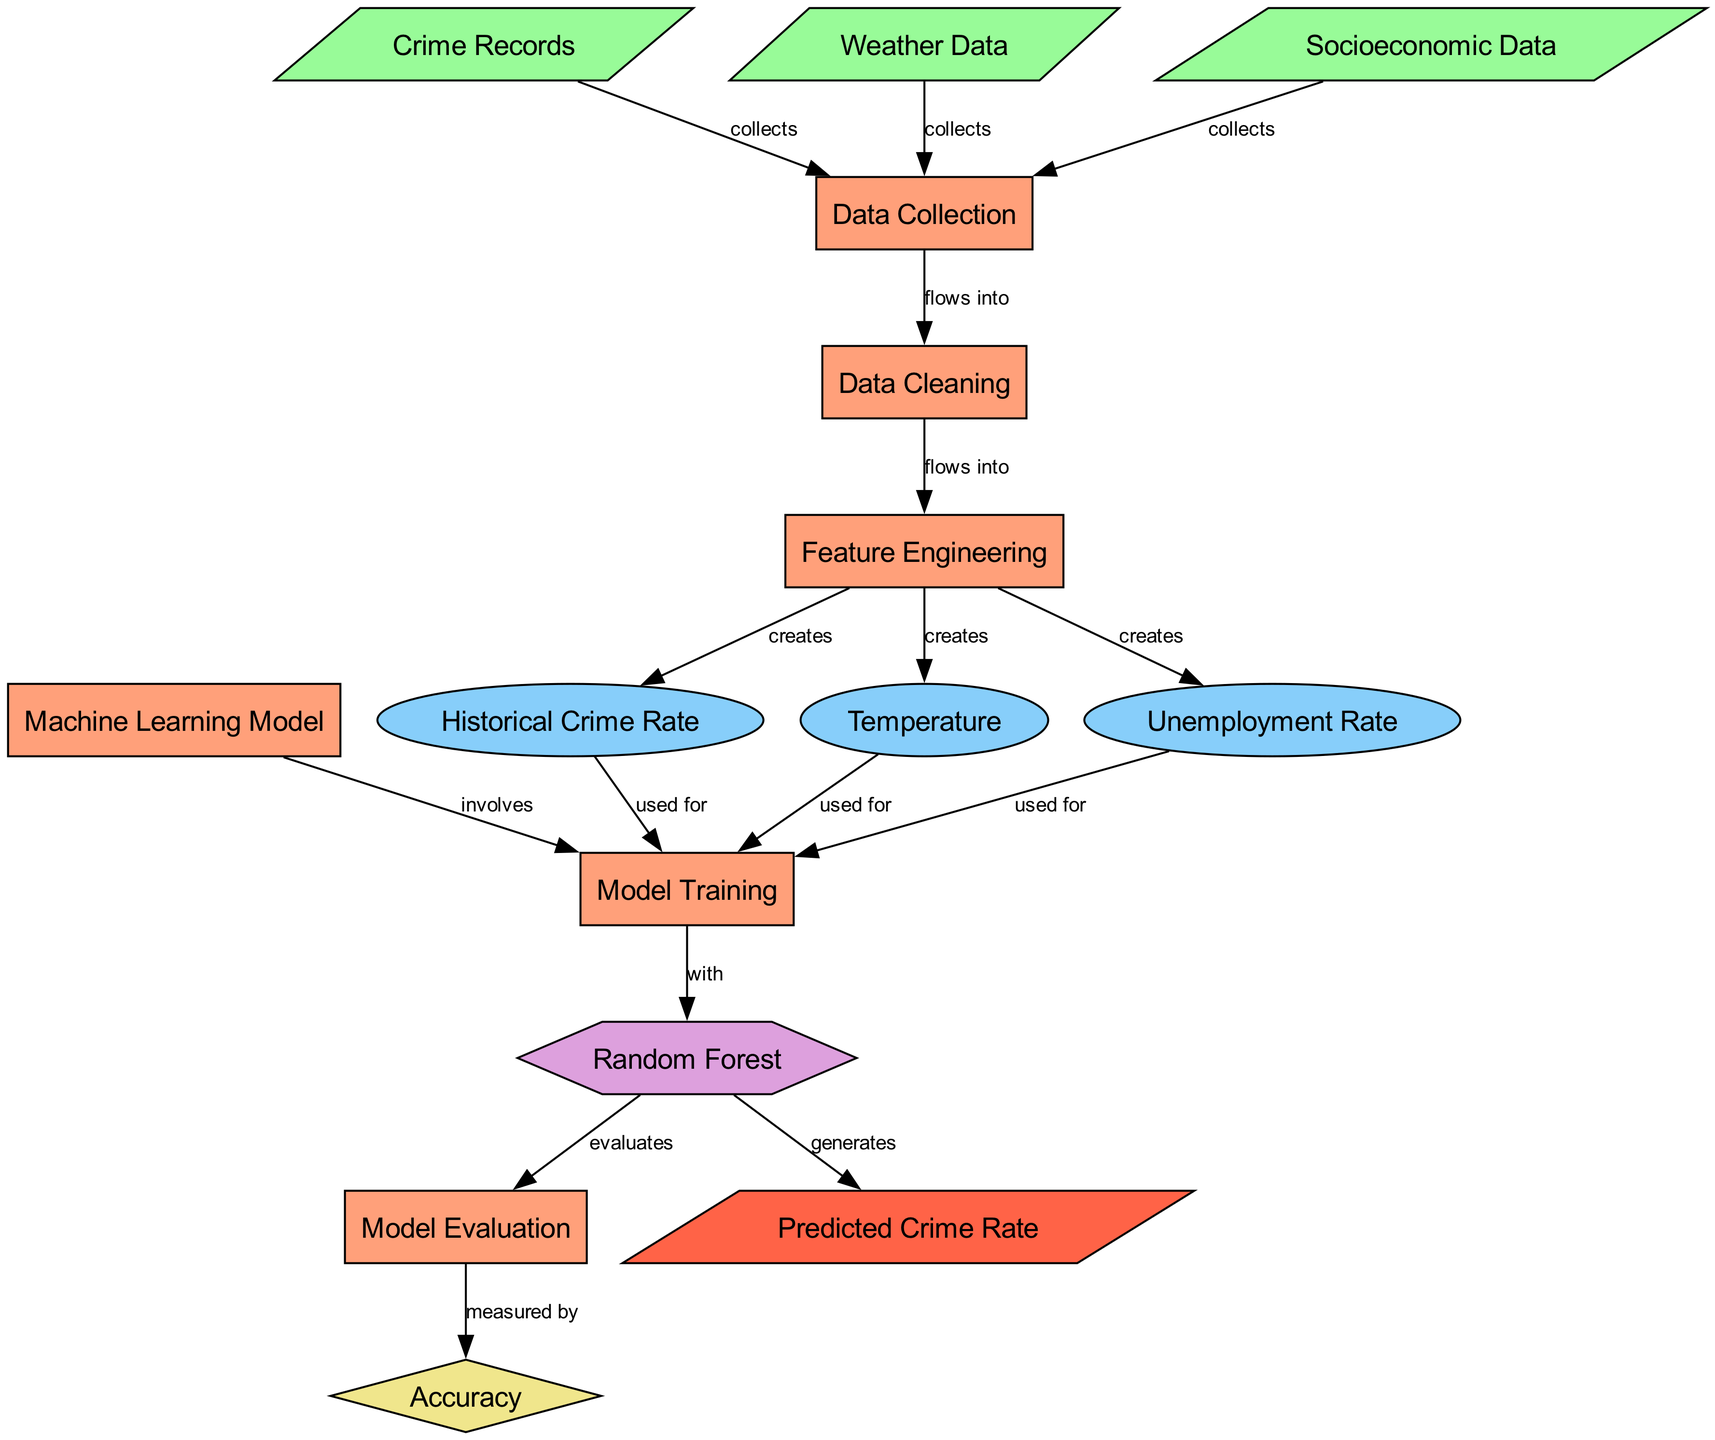What is the first step in the process of crime rate prediction? The first node in the process is labeled "Data Collection," which indicates it is the starting point for the entire workflow.
Answer: Data Collection How many input nodes are present in the diagram? By reviewing the nodes, we identify three input nodes: "Crime Records," "Weather Data," and "Socioeconomic Data." Counting these gives a total of three input nodes.
Answer: 3 Which features are created during the feature engineering step? The node labeled "Feature Engineering" connects to three feature nodes: "Historical Crime Rate," "Temperature," and "Unemployment Rate." Therefore, these three features are created in that step.
Answer: Historical Crime Rate, Temperature, Unemployment Rate What is the purpose of the machine learning model in this diagram? The node marked "Machine Learning Model" is a process that leads to "Model Training" and is involved in training the model with the created features, aiming to predict the crime rate based on the provided inputs.
Answer: To train the model What metric is used for evaluating the model's performance? The node connected to "Model Evaluation" is labeled "Accuracy," which indicates that the model's performance is measured by its accuracy.
Answer: Accuracy Which process step follows data cleaning in the diagram? After "Data Cleaning," the next step indicated in the diagram is "Feature Engineering," showing the workflow from one process to the next.
Answer: Feature Engineering What is the final output of the entire process? The last node in the sequence labeled "Predicted Crime Rate" represents the outcome of the previous steps in the diagram, indicating what is produced at the end of this analysis.
Answer: Predicted Crime Rate Which type of model is specifically mentioned for training? The diagram mentions "Random Forest," indicating this is the specific machine learning model used for the training process.
Answer: Random Forest How does socioeconomic data contribute to the process? Socioeconomic Data is collected and flows into the "Data Collection" stage, contributing as one of the inputs that helps shape the prediction process.
Answer: It is an input data source 